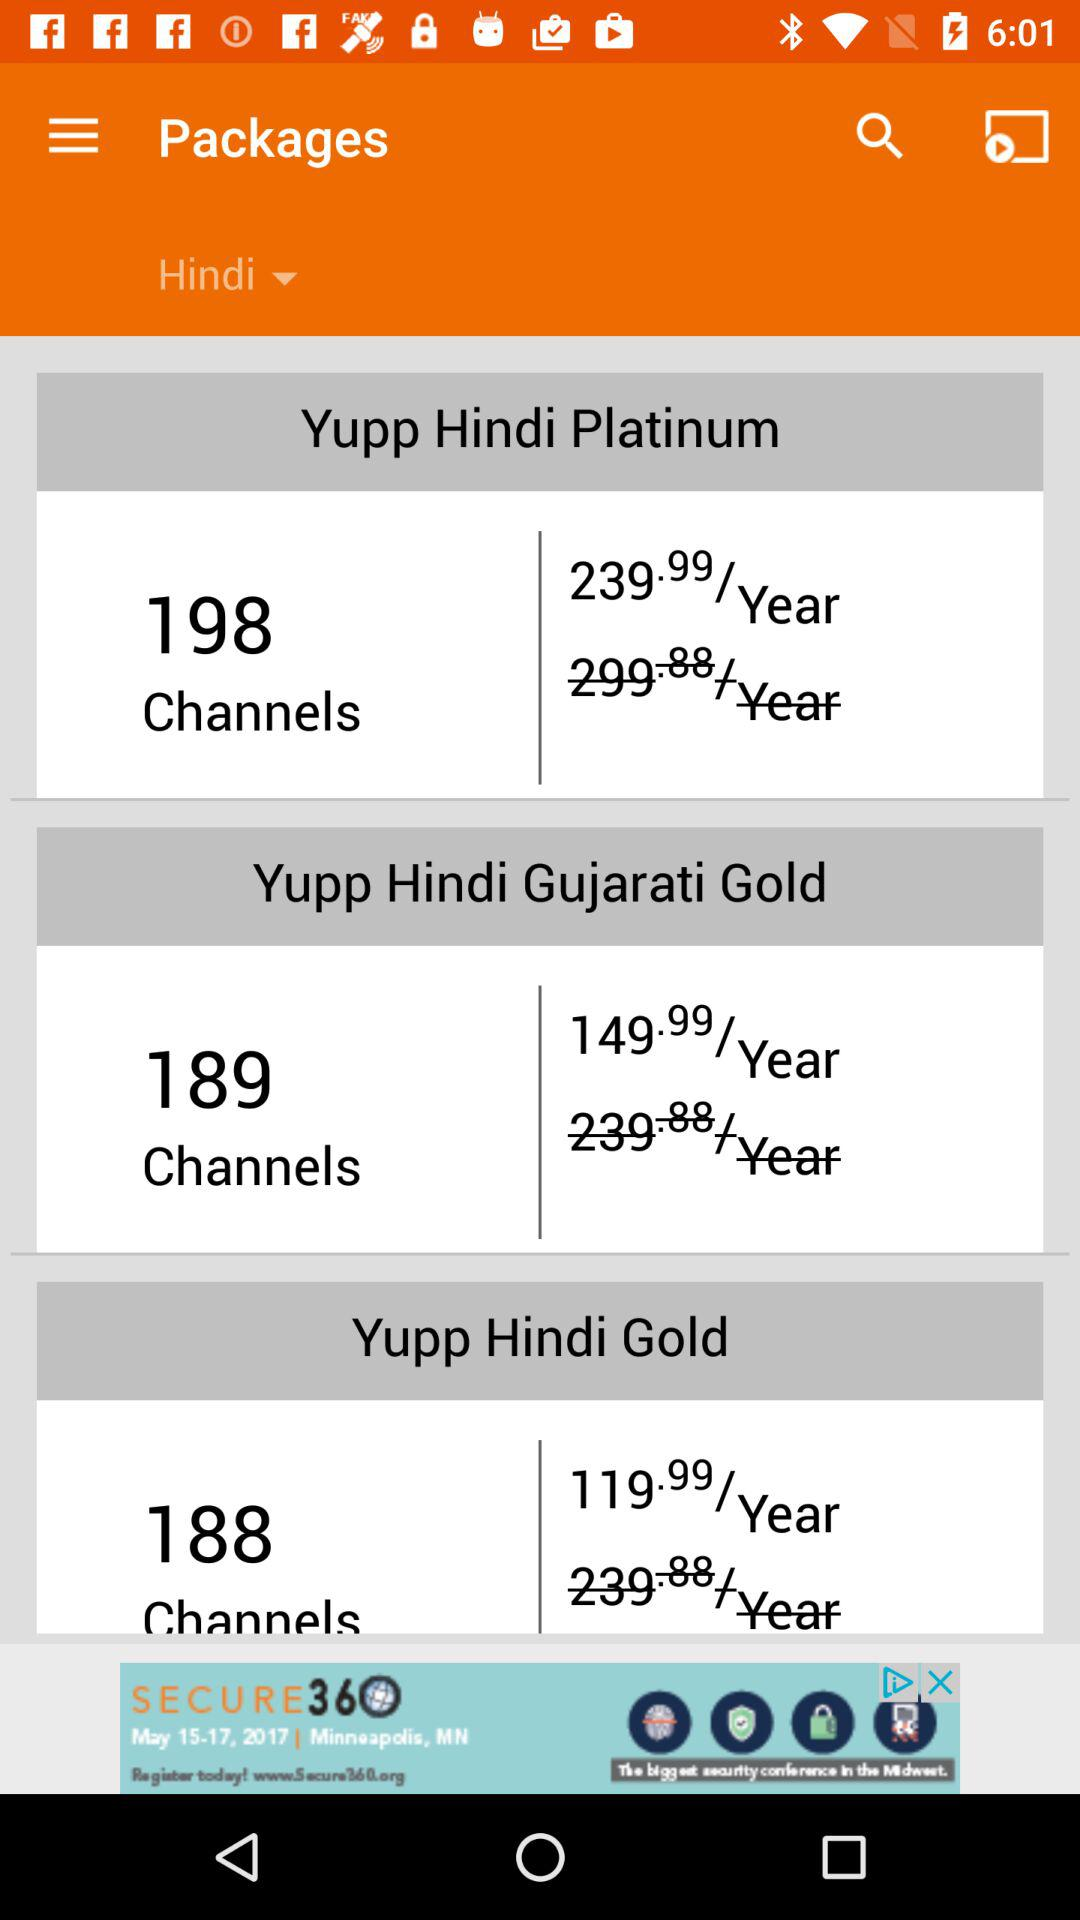How many channels are in "Yupp Hindi Platinum"? There are 198 channels in "Yupp Hindi Platinum". 